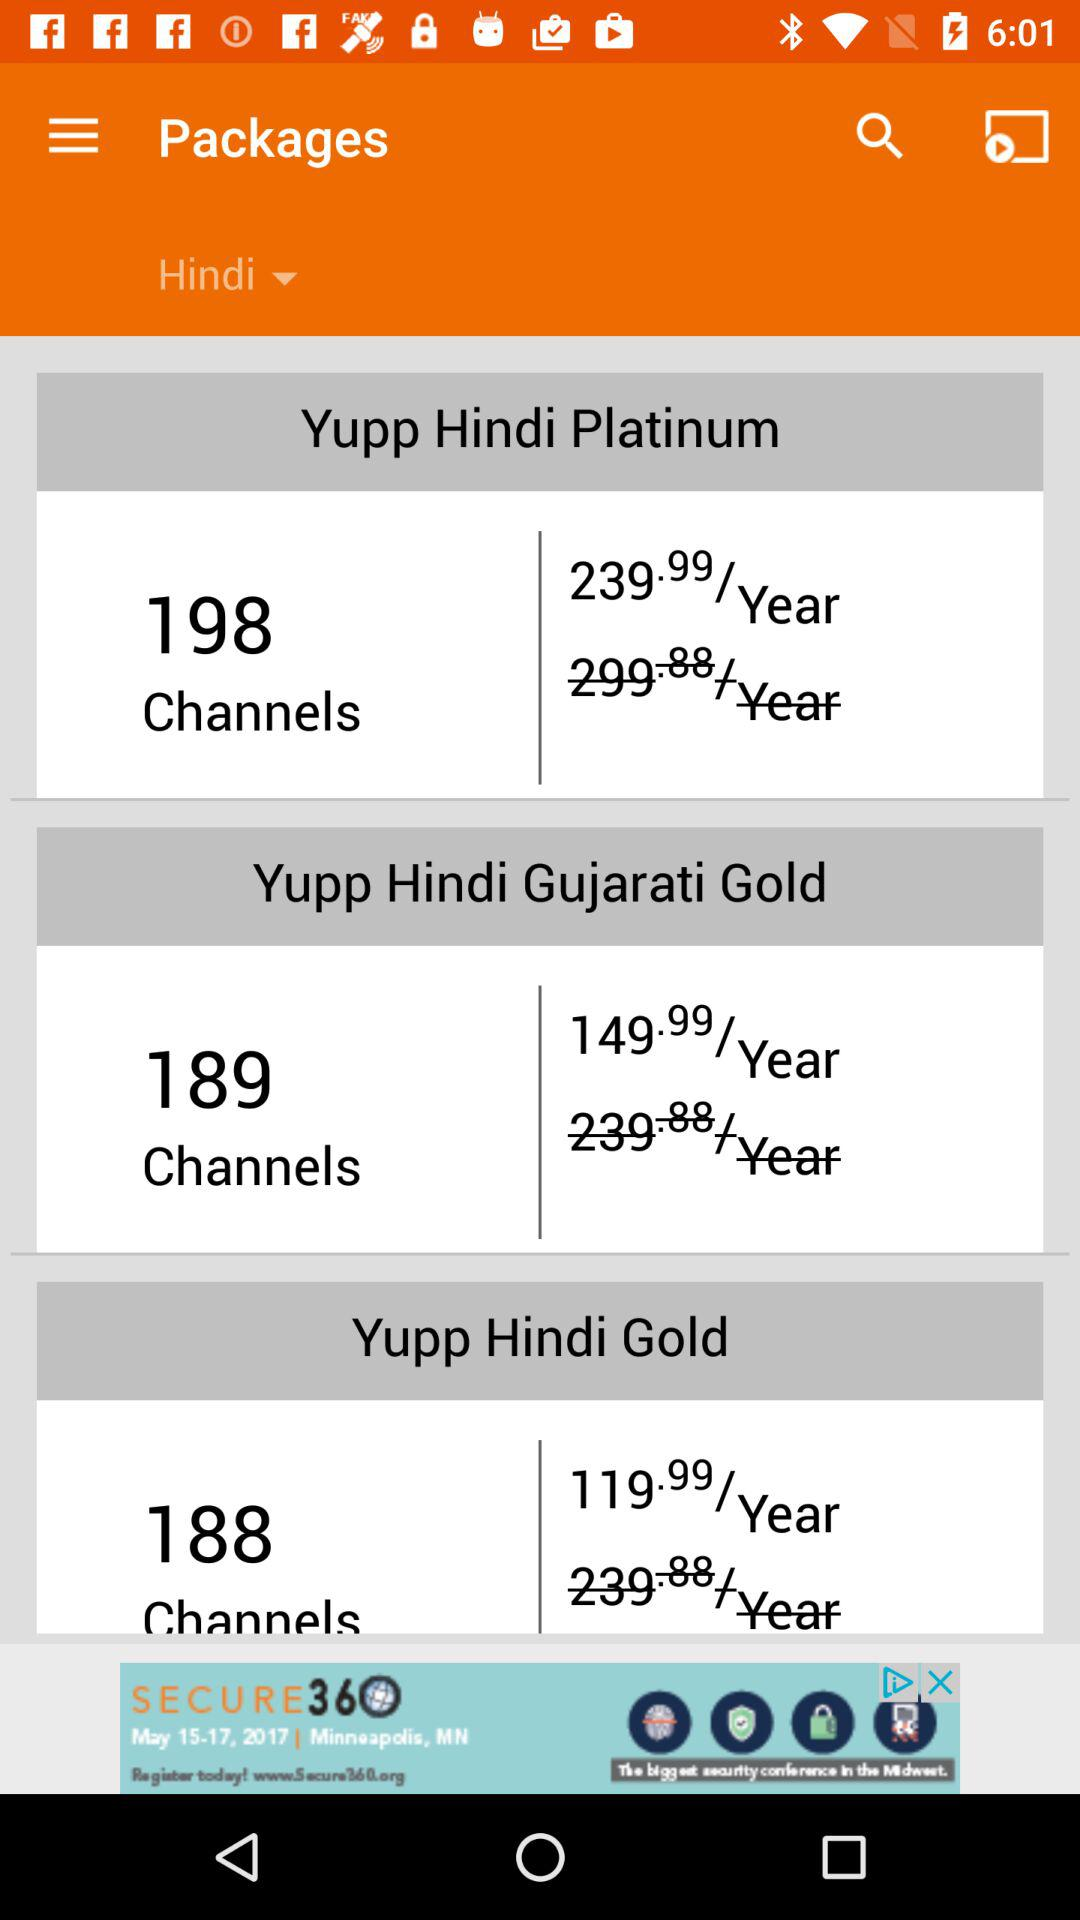How many channels are in "Yupp Hindi Platinum"? There are 198 channels in "Yupp Hindi Platinum". 